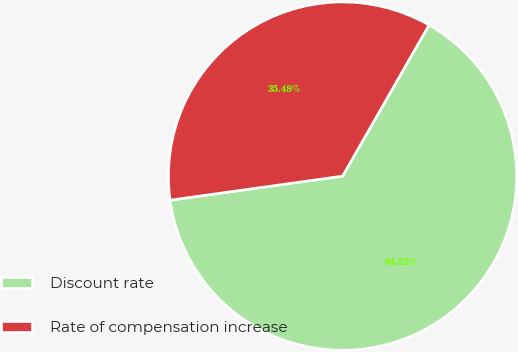Convert chart. <chart><loc_0><loc_0><loc_500><loc_500><pie_chart><fcel>Discount rate<fcel>Rate of compensation increase<nl><fcel>64.52%<fcel>35.48%<nl></chart> 